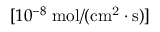Convert formula to latex. <formula><loc_0><loc_0><loc_500><loc_500>[ 1 0 ^ { - 8 } \, m o l / ( c m ^ { 2 } \cdot s ) ]</formula> 